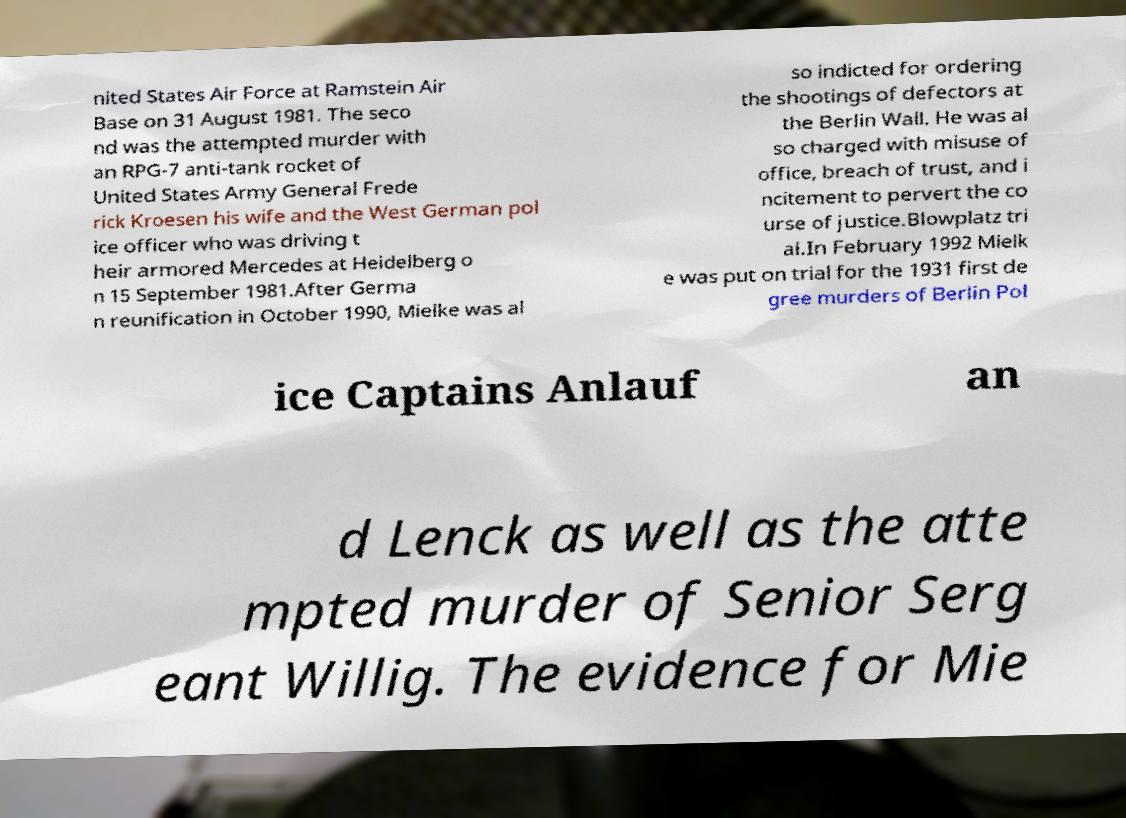Could you extract and type out the text from this image? nited States Air Force at Ramstein Air Base on 31 August 1981. The seco nd was the attempted murder with an RPG-7 anti-tank rocket of United States Army General Frede rick Kroesen his wife and the West German pol ice officer who was driving t heir armored Mercedes at Heidelberg o n 15 September 1981.After Germa n reunification in October 1990, Mielke was al so indicted for ordering the shootings of defectors at the Berlin Wall. He was al so charged with misuse of office, breach of trust, and i ncitement to pervert the co urse of justice.Blowplatz tri al.In February 1992 Mielk e was put on trial for the 1931 first de gree murders of Berlin Pol ice Captains Anlauf an d Lenck as well as the atte mpted murder of Senior Serg eant Willig. The evidence for Mie 